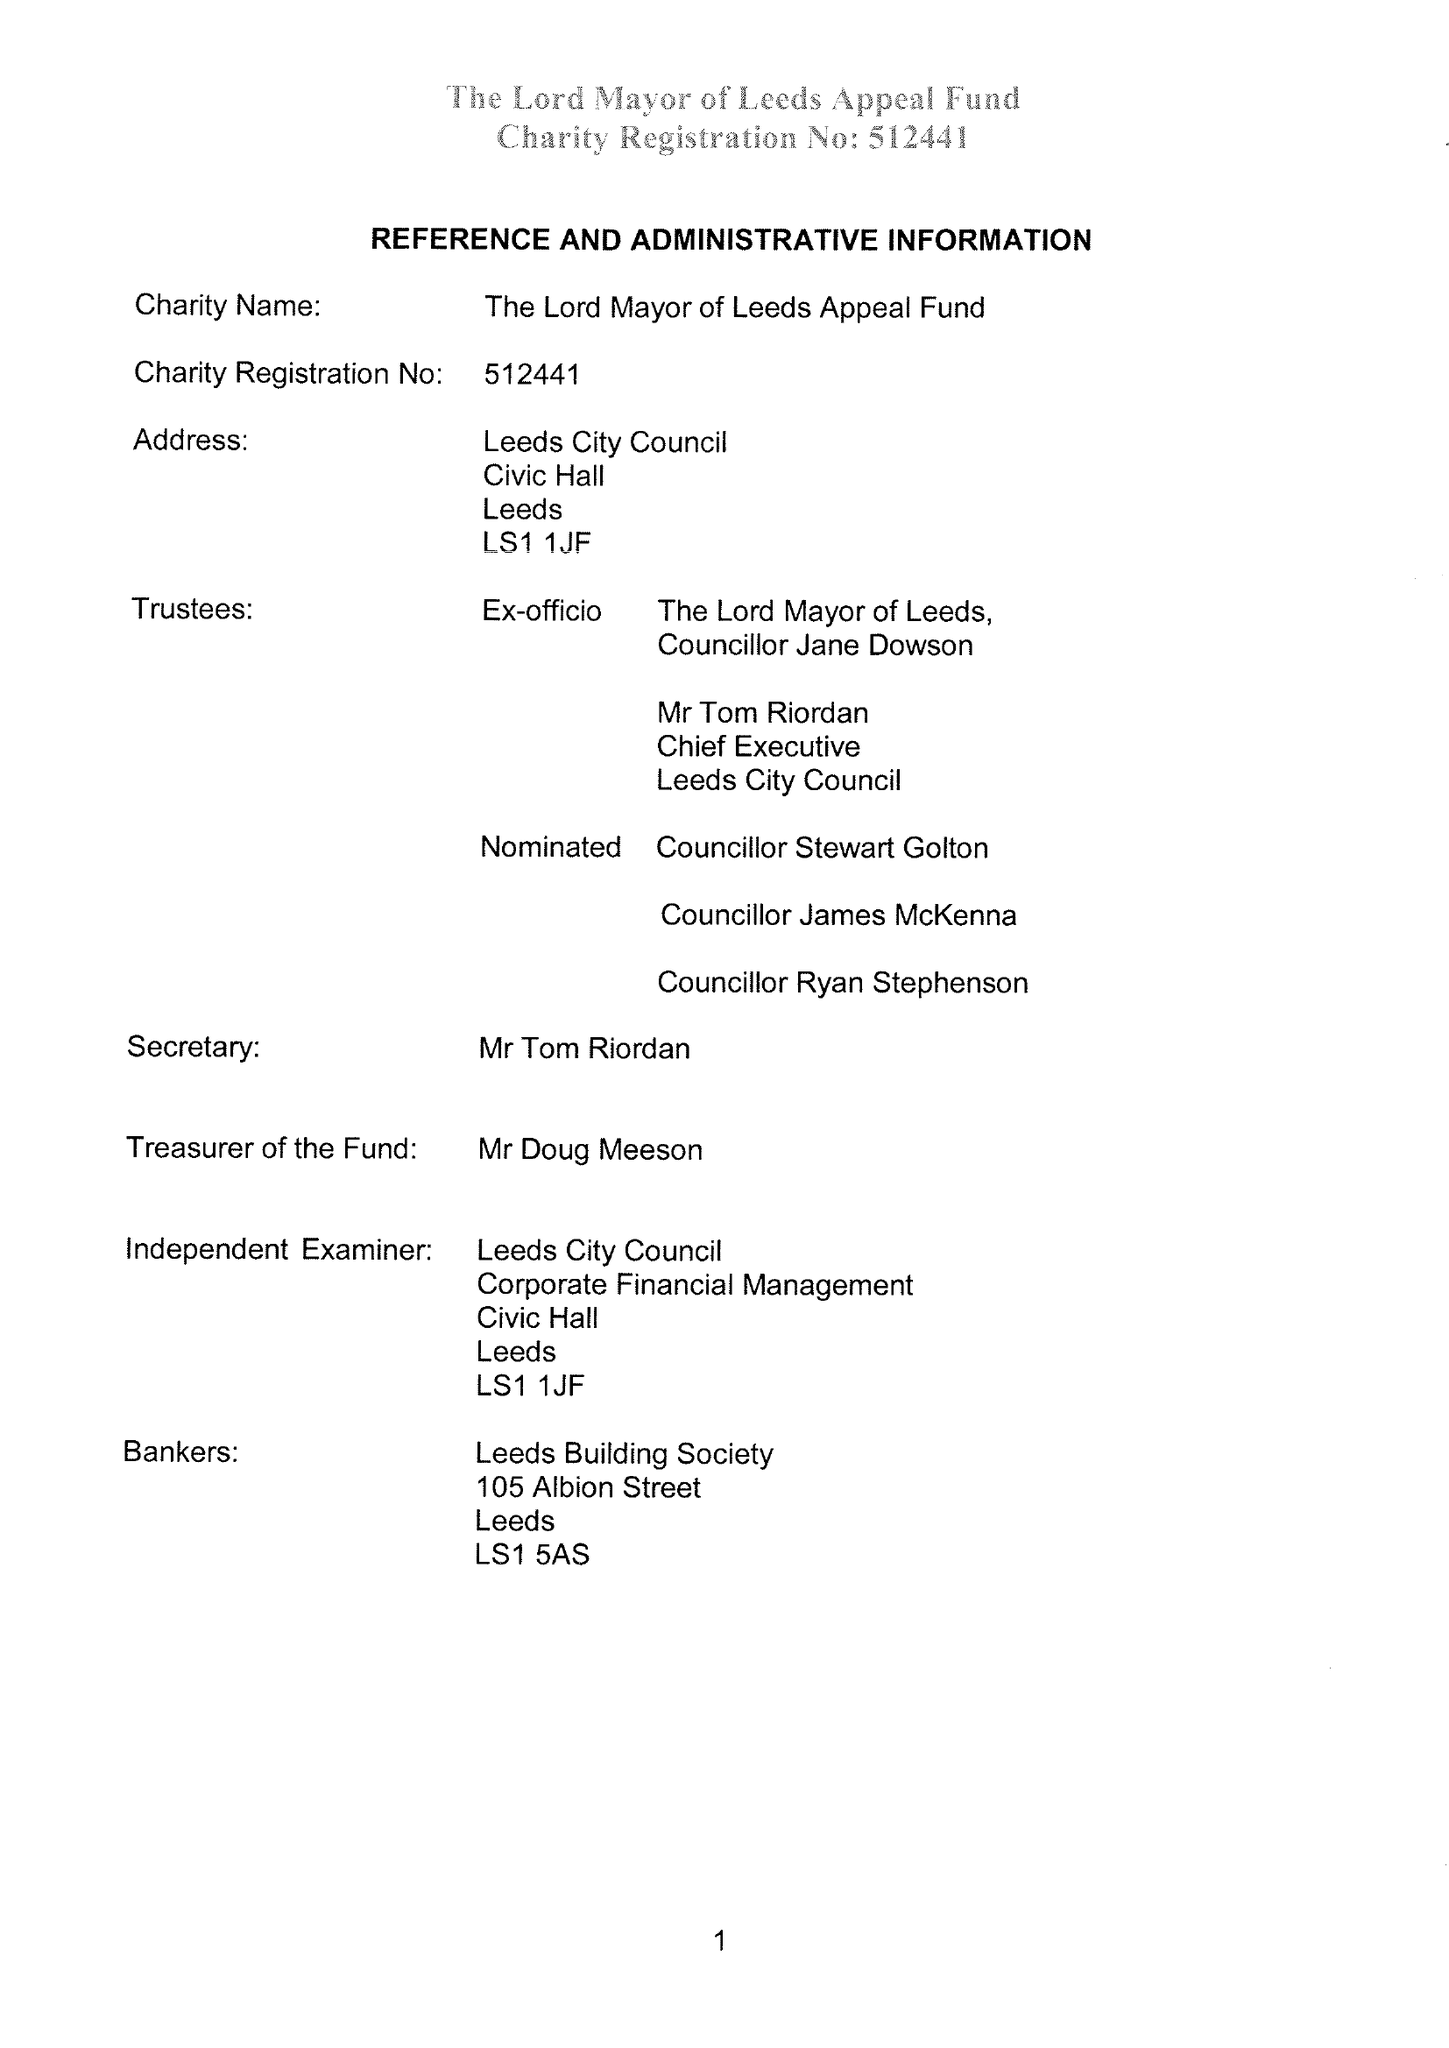What is the value for the spending_annually_in_british_pounds?
Answer the question using a single word or phrase. 61553.00 